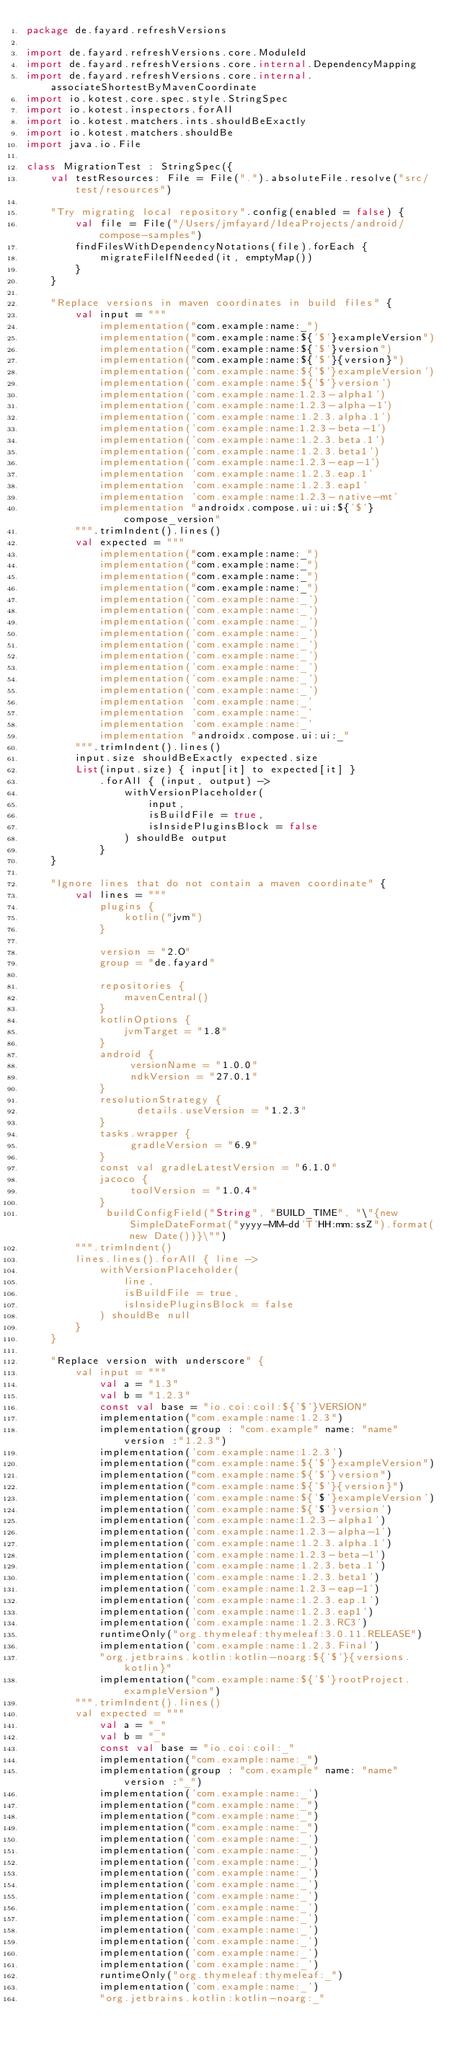Convert code to text. <code><loc_0><loc_0><loc_500><loc_500><_Kotlin_>package de.fayard.refreshVersions

import de.fayard.refreshVersions.core.ModuleId
import de.fayard.refreshVersions.core.internal.DependencyMapping
import de.fayard.refreshVersions.core.internal.associateShortestByMavenCoordinate
import io.kotest.core.spec.style.StringSpec
import io.kotest.inspectors.forAll
import io.kotest.matchers.ints.shouldBeExactly
import io.kotest.matchers.shouldBe
import java.io.File

class MigrationTest : StringSpec({
    val testResources: File = File(".").absoluteFile.resolve("src/test/resources")

    "Try migrating local repository".config(enabled = false) {
        val file = File("/Users/jmfayard/IdeaProjects/android/compose-samples")
        findFilesWithDependencyNotations(file).forEach {
            migrateFileIfNeeded(it, emptyMap())
        }
    }

    "Replace versions in maven coordinates in build files" {
        val input = """
            implementation("com.example:name:_")
            implementation("com.example:name:${'$'}exampleVersion")
            implementation("com.example:name:${'$'}version")
            implementation("com.example:name:${'$'}{version}")
            implementation('com.example:name:${'$'}exampleVersion')
            implementation('com.example:name:${'$'}version')
            implementation('com.example:name:1.2.3-alpha1')
            implementation('com.example:name:1.2.3-alpha-1')
            implementation('com.example:name:1.2.3.alpha.1')
            implementation('com.example:name:1.2.3-beta-1')
            implementation('com.example:name:1.2.3.beta.1')
            implementation('com.example:name:1.2.3.beta1')
            implementation('com.example:name:1.2.3-eap-1')
            implementation 'com.example:name:1.2.3.eap.1'
            implementation 'com.example:name:1.2.3.eap1'
            implementation 'com.example:name:1.2.3-native-mt'
            implementation "androidx.compose.ui:ui:${'$'}compose_version"
        """.trimIndent().lines()
        val expected = """
            implementation("com.example:name:_")
            implementation("com.example:name:_")
            implementation("com.example:name:_")
            implementation("com.example:name:_")
            implementation('com.example:name:_')
            implementation('com.example:name:_')
            implementation('com.example:name:_')
            implementation('com.example:name:_')
            implementation('com.example:name:_')
            implementation('com.example:name:_')
            implementation('com.example:name:_')
            implementation('com.example:name:_')
            implementation('com.example:name:_')
            implementation 'com.example:name:_'
            implementation 'com.example:name:_'
            implementation 'com.example:name:_'
            implementation "androidx.compose.ui:ui:_"
        """.trimIndent().lines()
        input.size shouldBeExactly expected.size
        List(input.size) { input[it] to expected[it] }
            .forAll { (input, output) ->
                withVersionPlaceholder(
                    input,
                    isBuildFile = true,
                    isInsidePluginsBlock = false
                ) shouldBe output
            }
    }

    "Ignore lines that do not contain a maven coordinate" {
        val lines = """
            plugins {
                kotlin("jvm")
            }

            version = "2.O"
            group = "de.fayard"

            repositories {
                mavenCentral()
            }
            kotlinOptions {
                jvmTarget = "1.8"
            }
            android {
                 versionName = "1.0.0"
                 ndkVersion = "27.0.1"
            }
            resolutionStrategy {
                  details.useVersion = "1.2.3"
            }
            tasks.wrapper {
                 gradleVersion = "6.9"
            }
            const val gradleLatestVersion = "6.1.0"
            jacoco {
                 toolVersion = "1.0.4"
            }
             buildConfigField("String", "BUILD_TIME", "\"{new SimpleDateFormat("yyyy-MM-dd'T'HH:mm:ssZ").format(new Date())}\"")
        """.trimIndent()
        lines.lines().forAll { line ->
            withVersionPlaceholder(
                line,
                isBuildFile = true,
                isInsidePluginsBlock = false
            ) shouldBe null
        }
    }

    "Replace version with underscore" {
        val input = """
            val a = "1.3"
            val b = "1.2.3"
            const val base = "io.coi:coil:${'$'}VERSION"
            implementation("com.example:name:1.2.3")
            implementation(group : "com.example" name: "name" version :"1.2.3")
            implementation('com.example:name:1.2.3')
            implementation("com.example:name:${'$'}exampleVersion")
            implementation("com.example:name:${'$'}version")
            implementation("com.example:name:${'$'}{version}")
            implementation('com.example:name:${'$'}exampleVersion')
            implementation('com.example:name:${'$'}version')
            implementation('com.example:name:1.2.3-alpha1')
            implementation('com.example:name:1.2.3-alpha-1')
            implementation('com.example:name:1.2.3.alpha.1')
            implementation('com.example:name:1.2.3-beta-1')
            implementation('com.example:name:1.2.3.beta.1')
            implementation('com.example:name:1.2.3.beta1')
            implementation('com.example:name:1.2.3-eap-1')
            implementation('com.example:name:1.2.3.eap.1')
            implementation('com.example:name:1.2.3.eap1')
            implementation('com.example:name:1.2.3.RC3')
            runtimeOnly("org.thymeleaf:thymeleaf:3.0.11.RELEASE")
            implementation('com.example:name:1.2.3.Final')
            "org.jetbrains.kotlin:kotlin-noarg:${'$'}{versions.kotlin}"
            implementation("com.example:name:${'$'}rootProject.exampleVersion")
        """.trimIndent().lines()
        val expected = """
            val a = "_"
            val b = "_"
            const val base = "io.coi:coil:_"
            implementation("com.example:name:_")
            implementation(group : "com.example" name: "name" version :"_")
            implementation('com.example:name:_')
            implementation("com.example:name:_")
            implementation("com.example:name:_")
            implementation("com.example:name:_")
            implementation('com.example:name:_')
            implementation('com.example:name:_')
            implementation('com.example:name:_')
            implementation('com.example:name:_')
            implementation('com.example:name:_')
            implementation('com.example:name:_')
            implementation('com.example:name:_')
            implementation('com.example:name:_')
            implementation('com.example:name:_')
            implementation('com.example:name:_')
            implementation('com.example:name:_')
            implementation('com.example:name:_')
            runtimeOnly("org.thymeleaf:thymeleaf:_")
            implementation('com.example:name:_')
            "org.jetbrains.kotlin:kotlin-noarg:_"</code> 